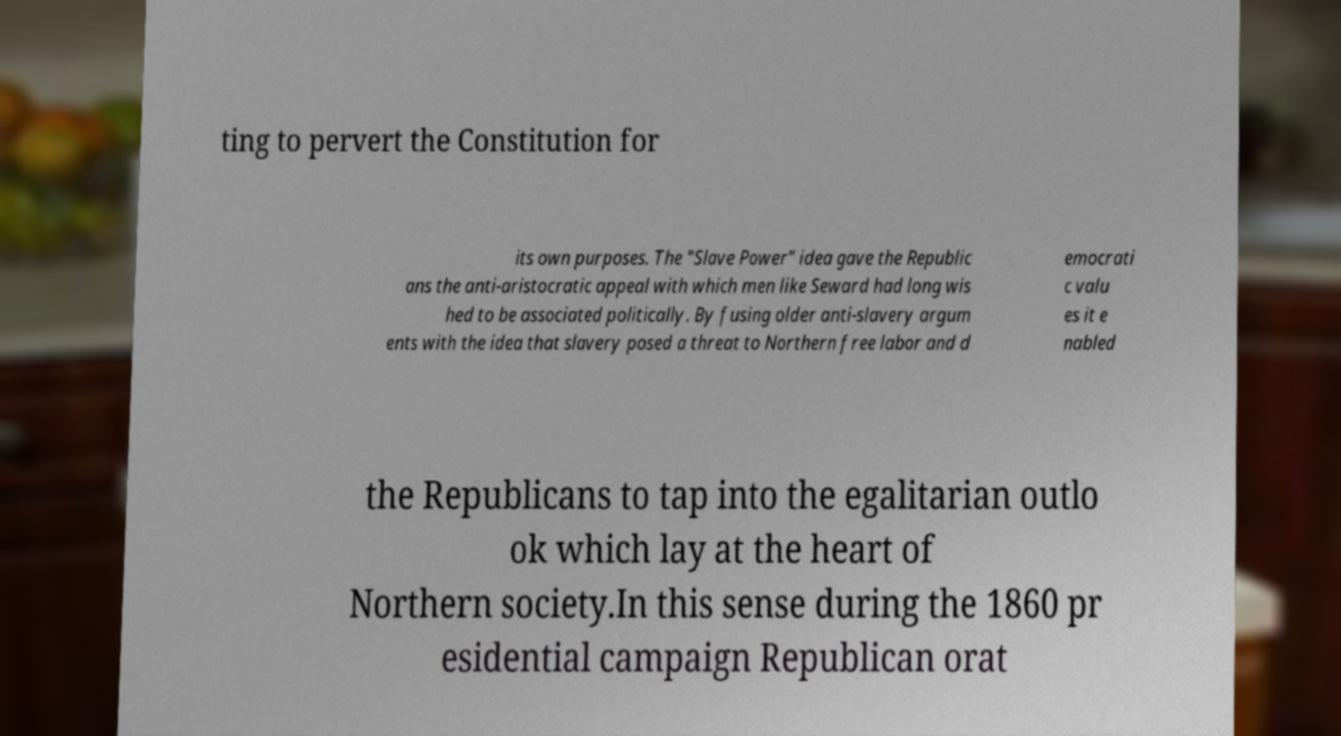I need the written content from this picture converted into text. Can you do that? ting to pervert the Constitution for its own purposes. The "Slave Power" idea gave the Republic ans the anti-aristocratic appeal with which men like Seward had long wis hed to be associated politically. By fusing older anti-slavery argum ents with the idea that slavery posed a threat to Northern free labor and d emocrati c valu es it e nabled the Republicans to tap into the egalitarian outlo ok which lay at the heart of Northern society.In this sense during the 1860 pr esidential campaign Republican orat 